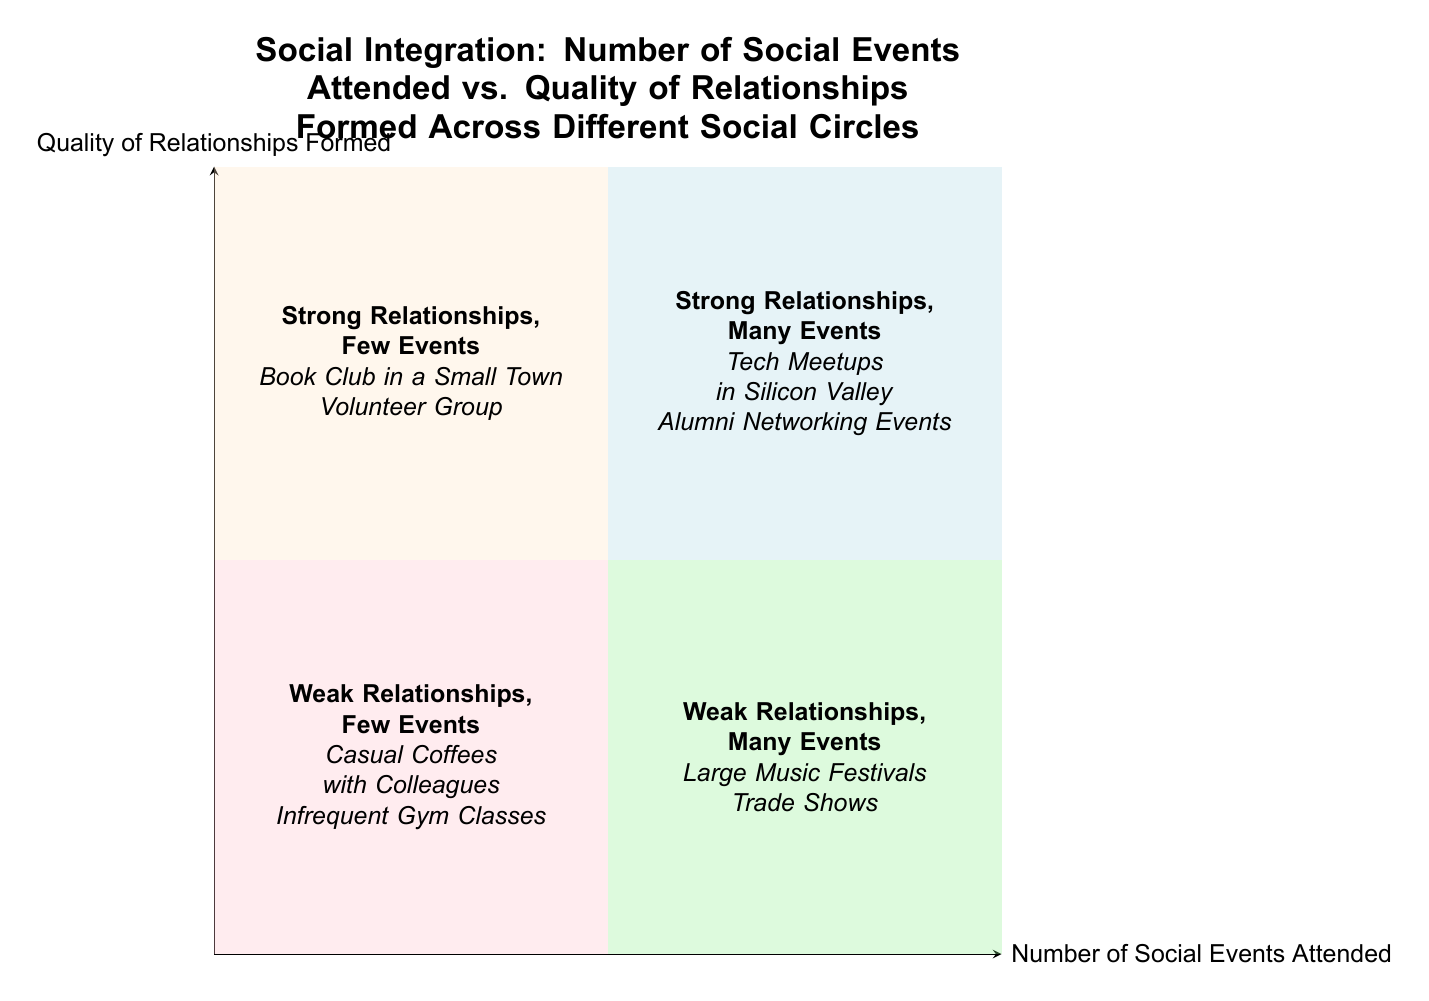What are the characteristics of the "Top-Left" quadrant? The "Top-Left" quadrant is characterized by "High quality interactions," "Deep connections," and "Infrequent meetings."
Answer: High quality interactions, Deep connections, Infrequent meetings How many examples are provided for the "Bottom-Right" quadrant? The "Bottom-Right" quadrant includes two examples: "Large Music Festivals" and "Trade Shows," so the total is two examples.
Answer: Two What is the main difference between the "Top-Right" and "Bottom-Right" quadrants? The "Top-Right" quadrant features "Strong Relationships, Many Events," while the "Bottom-Right" quadrant features "Weak Relationships, Many Events." This indicates that the quality of relationships differs significantly between these two quadrants, despite both having a high number of events.
Answer: Strong Relationships vs. Weak Relationships Name an example from the "Bottom-Left" quadrant. An example from the "Bottom-Left" quadrant is "Casual Coffees with Colleagues."
Answer: Casual Coffees with Colleagues Which quadrant contains the strongest relationships? The "Top-Left" and "Top-Right" quadrants both contain strong relationships, but the "Top-Right" quadrant has many events.
Answer: Top-Left and Top-Right What type of relationships are formed in the "Top-Left" quadrant? In the "Top-Left" quadrant, the relationships formed are "Strong Relationships." This means that the nature of these connections is significant and enriching despite the limited number of events.
Answer: Strong Relationships Which quadrant has high interaction frequency but shallow connections? The "Bottom-Right" quadrant features high frequency of interactions but shallow connections. This means that, while many people engage, the depth of relationships does not develop significantly.
Answer: Bottom-Right How do the characteristics differ between the "Top-Left" and "Bottom-Left" quadrants? The "Top-Left" quadrant is characterized by "High quality interactions" and "Deep connections," while the "Bottom-Left" quadrant has "Sparse interactions" and "Limited social bonds." This shows a contrast in both the quality and frequency of interactions.
Answer: Quality vs. Quantity 